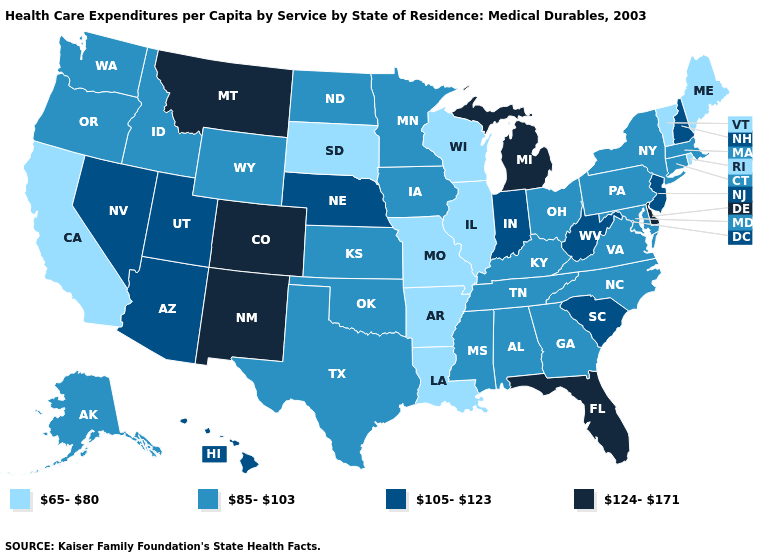Among the states that border Mississippi , does Louisiana have the lowest value?
Concise answer only. Yes. What is the value of Oklahoma?
Keep it brief. 85-103. What is the value of Montana?
Short answer required. 124-171. Name the states that have a value in the range 65-80?
Give a very brief answer. Arkansas, California, Illinois, Louisiana, Maine, Missouri, Rhode Island, South Dakota, Vermont, Wisconsin. What is the value of Michigan?
Keep it brief. 124-171. Which states have the lowest value in the USA?
Concise answer only. Arkansas, California, Illinois, Louisiana, Maine, Missouri, Rhode Island, South Dakota, Vermont, Wisconsin. Which states have the lowest value in the Northeast?
Keep it brief. Maine, Rhode Island, Vermont. Name the states that have a value in the range 105-123?
Short answer required. Arizona, Hawaii, Indiana, Nebraska, Nevada, New Hampshire, New Jersey, South Carolina, Utah, West Virginia. What is the lowest value in the Northeast?
Be succinct. 65-80. Does the map have missing data?
Short answer required. No. Name the states that have a value in the range 85-103?
Keep it brief. Alabama, Alaska, Connecticut, Georgia, Idaho, Iowa, Kansas, Kentucky, Maryland, Massachusetts, Minnesota, Mississippi, New York, North Carolina, North Dakota, Ohio, Oklahoma, Oregon, Pennsylvania, Tennessee, Texas, Virginia, Washington, Wyoming. What is the value of Georgia?
Write a very short answer. 85-103. Among the states that border Alabama , does Mississippi have the lowest value?
Write a very short answer. Yes. What is the value of Michigan?
Be succinct. 124-171. Name the states that have a value in the range 85-103?
Quick response, please. Alabama, Alaska, Connecticut, Georgia, Idaho, Iowa, Kansas, Kentucky, Maryland, Massachusetts, Minnesota, Mississippi, New York, North Carolina, North Dakota, Ohio, Oklahoma, Oregon, Pennsylvania, Tennessee, Texas, Virginia, Washington, Wyoming. 